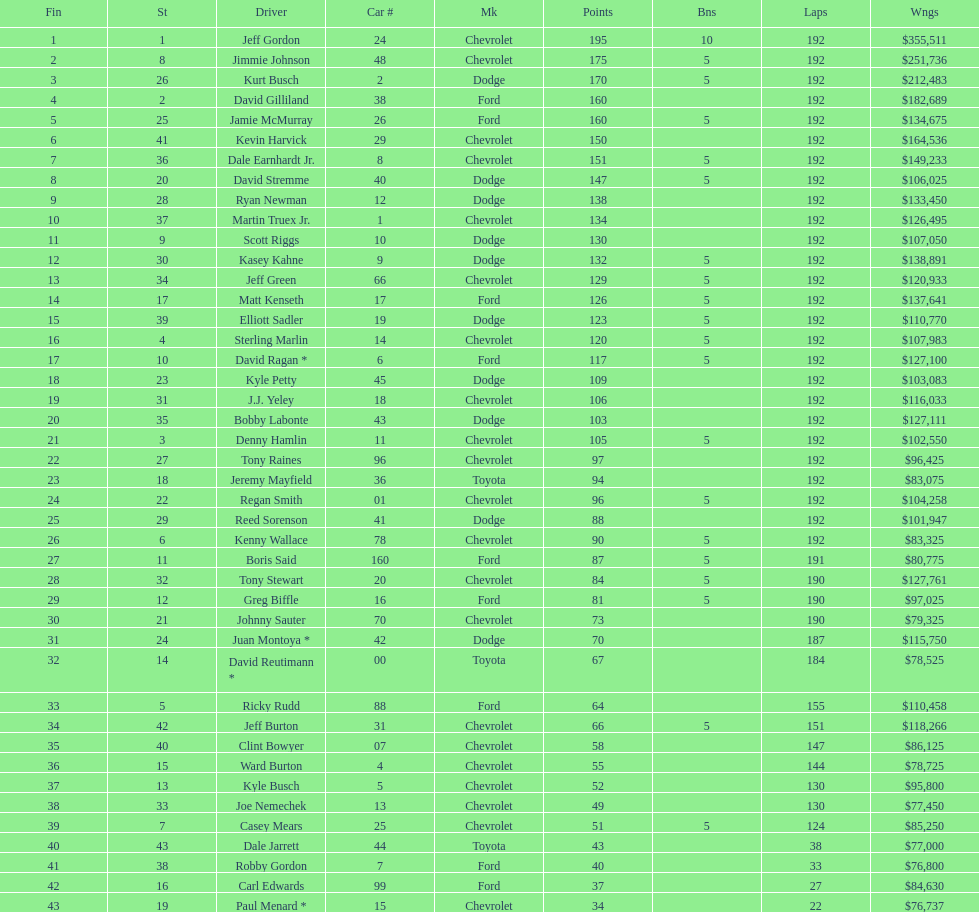What make did kurt busch drive? Dodge. 